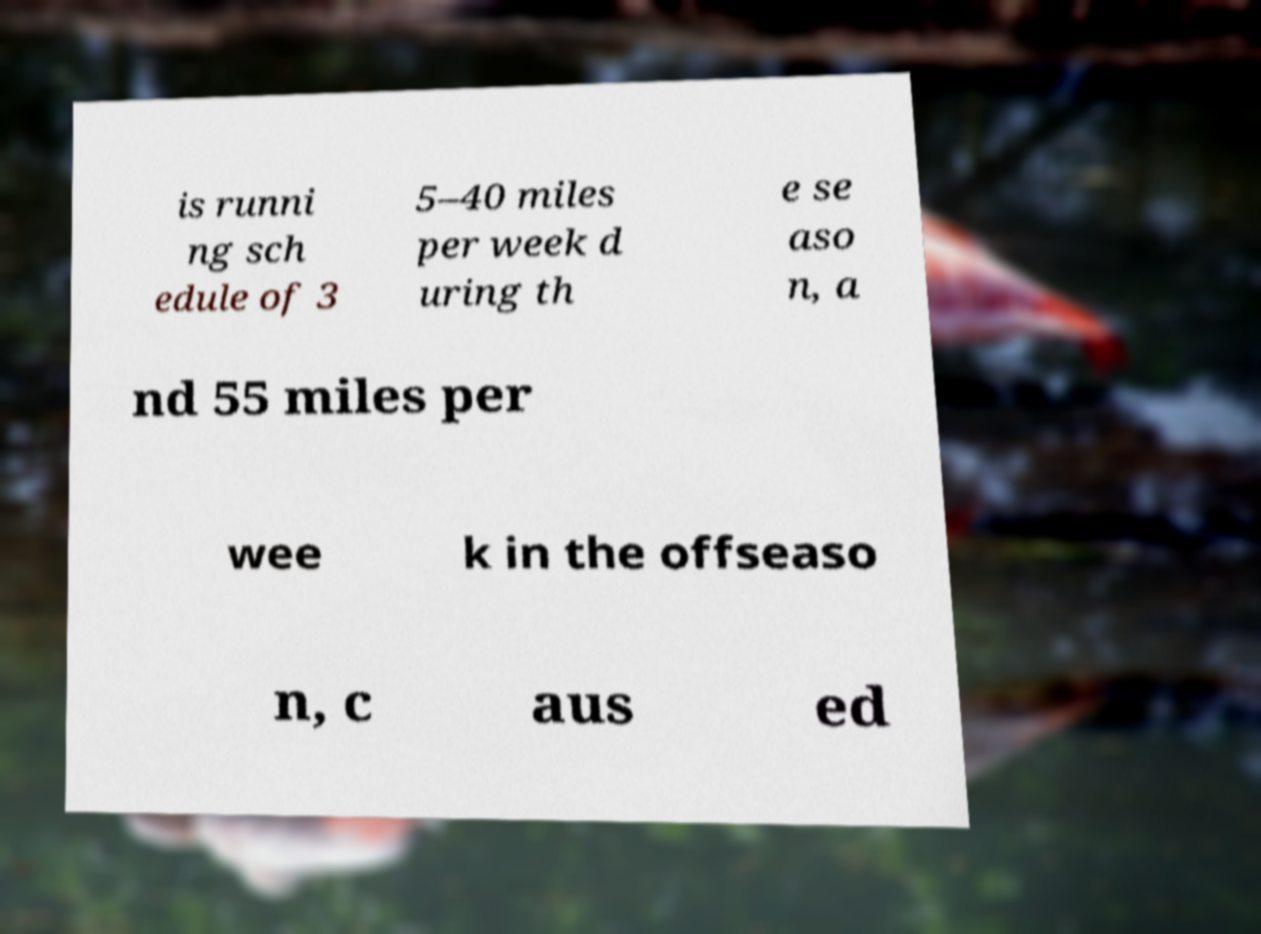Please identify and transcribe the text found in this image. is runni ng sch edule of 3 5–40 miles per week d uring th e se aso n, a nd 55 miles per wee k in the offseaso n, c aus ed 